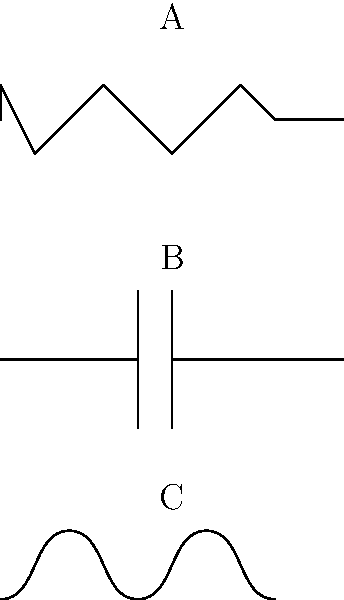As a professional football player who has been involved in charity work for young athletes during the pandemic, you've decided to expand your knowledge into various fields, including electrical engineering. Identify the electrical components represented by the schematic symbols labeled A, B, and C in the diagram above. To identify the electrical components from their schematic symbols, let's analyze each one:

1. Symbol A:
   - This symbol consists of a zigzag line between two connection points.
   - The zigzag pattern represents resistance to the flow of electric current.
   - This is the standard symbol for a resistor in electrical schematics.

2. Symbol B:
   - This symbol shows two parallel lines perpendicular to the direction of the circuit.
   - These parallel lines represent two conductive plates separated by a dielectric material.
   - This is the standard symbol for a capacitor in electrical schematics.

3. Symbol C:
   - This symbol displays a series of loops or coils.
   - The coiled pattern represents a wire wound around a core to create a magnetic field.
   - This is the standard symbol for an inductor in electrical schematics.

By recognizing these distinct patterns, we can identify the components represented by each symbol.
Answer: A: Resistor, B: Capacitor, C: Inductor 